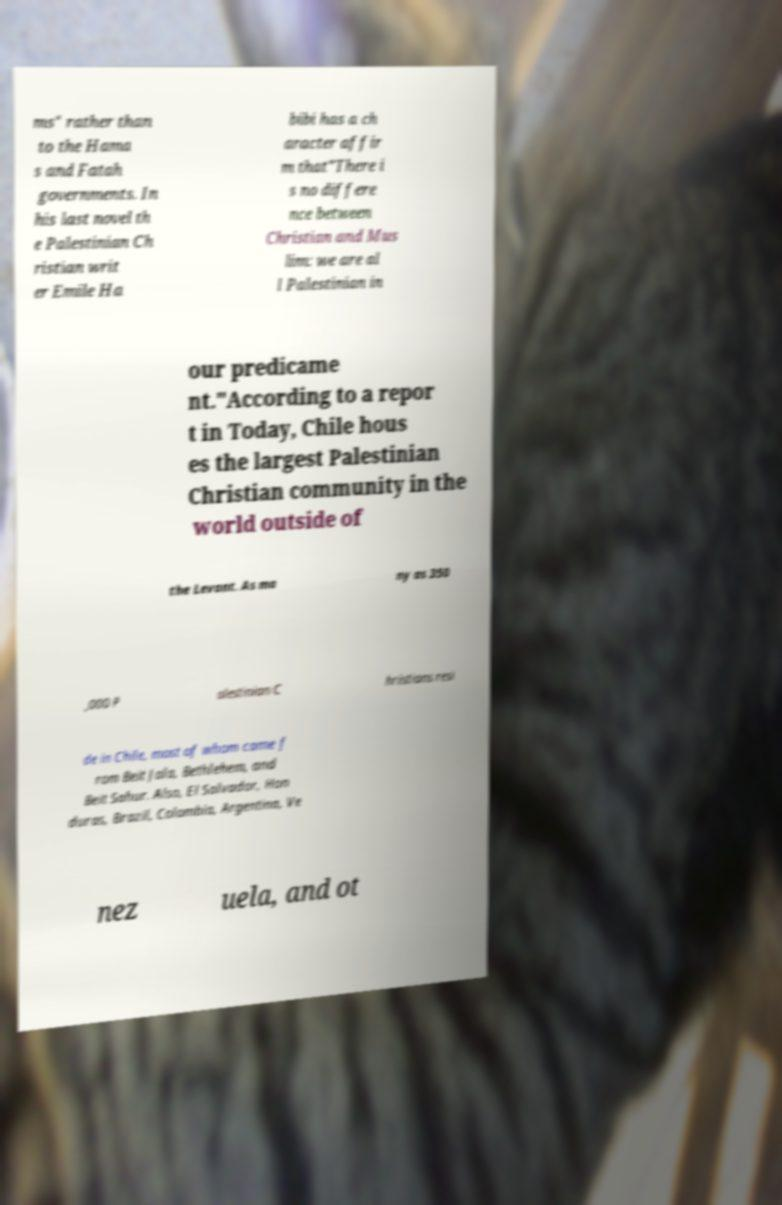Could you assist in decoding the text presented in this image and type it out clearly? ms" rather than to the Hama s and Fatah governments. In his last novel th e Palestinian Ch ristian writ er Emile Ha bibi has a ch aracter affir m that"There i s no differe nce between Christian and Mus lim: we are al l Palestinian in our predicame nt."According to a repor t in Today, Chile hous es the largest Palestinian Christian community in the world outside of the Levant. As ma ny as 350 ,000 P alestinian C hristians resi de in Chile, most of whom came f rom Beit Jala, Bethlehem, and Beit Sahur. Also, El Salvador, Hon duras, Brazil, Colombia, Argentina, Ve nez uela, and ot 